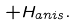Convert formula to latex. <formula><loc_0><loc_0><loc_500><loc_500>+ H _ { a n i s } .</formula> 